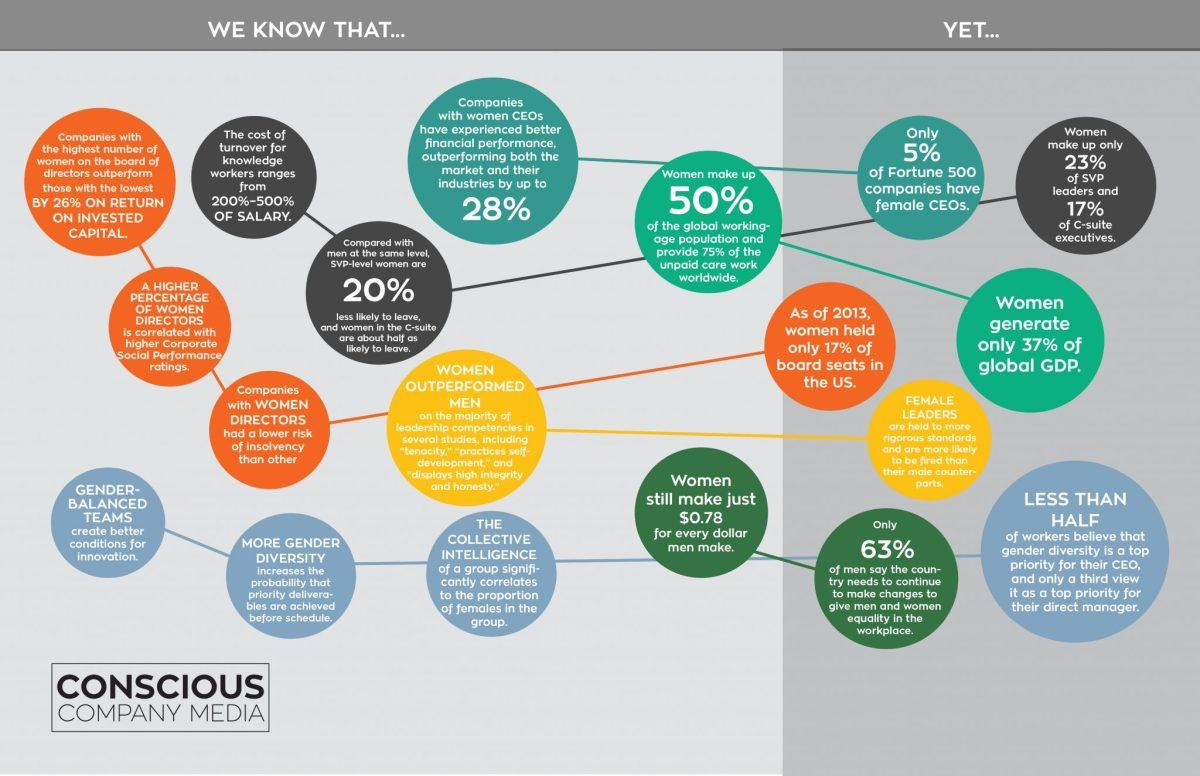Highlight a few significant elements in this photo. A significant percentage of women in the C-suite are unlikely to leave their positions, with 50% being the threshold for this likelihood. According to recent estimates, women account for 37% of the global Gross Domestic Product (GDP). Increasing the percentage of women directors on a company's board is correlated with higher corporate social performance ratings. Gender-balanced teams are more conducive to innovation than teams with an imbalance of males or females. It is commonly believed that women are held to more rigorous standards and are more likely to be fired than men. 